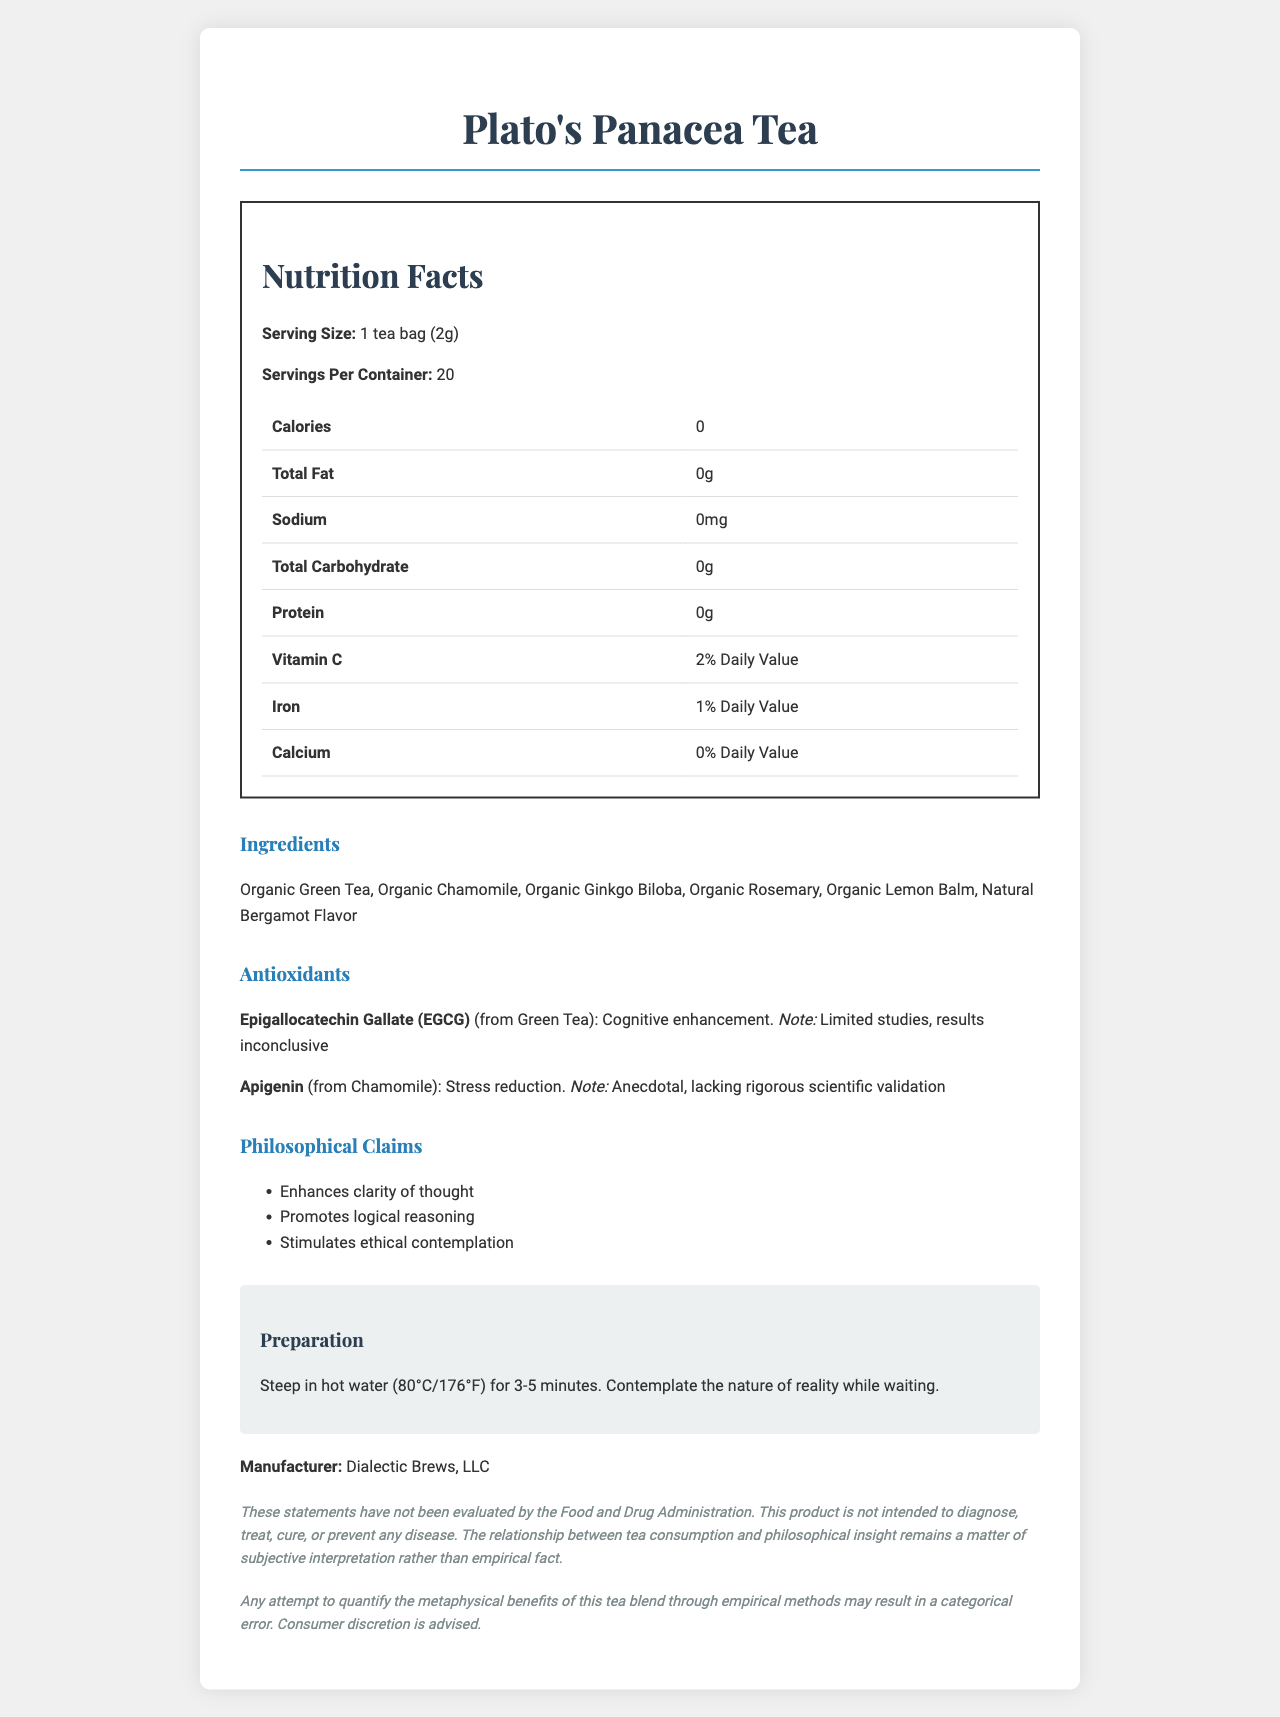what is the serving size of Plato's Panacea Tea? The document specifies the serving size as "1 tea bag (2g)" in the Nutrition Facts section.
Answer: 1 tea bag (2g) how many servings are there per container? The document states "Servings Per Container: 20" in the Nutrition Facts section.
Answer: 20 what is the percentage of Daily Value for Vitamin C in this tea? The document mentions "Vitamin C: 2% Daily Value" in the Nutrition Facts section.
Answer: 2% list three ingredients of this tea blend. The document lists ingredients as "Organic Green Tea, Organic Chamomile, Organic Ginkgo Biloba, Organic Rosemary, Organic Lemon Balm, Natural Bergamot Flavor".
Answer: Organic Green Tea, Organic Chamomile, Organic Ginkgo Biloba which antioxidant is known for cognitive enhancement? A. Apigenin B. EGCG C. Catechin D. Quercetin The document lists "Epigallocatechin Gallate (EGCG)" from Green Tea as having the purported benefit of "Cognitive enhancement".
Answer: B what is the source of Apigenin in this tea? The document specifies that Apigenin comes from Chamomile in the Antioxidants section.
Answer: Chamomile does this tea contain any protein? The document states "Protein: 0g" in the Nutrition Facts section.
Answer: No which company manufactures Plato's Panacea Tea? The document lists the manufacturer as "Dialectic Brews, LLC".
Answer: Dialectic Brews, LLC what temperature should the water be for preparing the tea? The document states "Steep in hot water (80°C/176°F) for 3-5 minutes" in the Preparation section.
Answer: 80°C/176°F has the FDA evaluated the philosophical claims of this tea? The disclaimer in the document mentions, "These statements have not been evaluated by the Food and Drug Administration".
Answer: No which of the following is not an ingredient in the tea? A. Organic Green Tea B. Organic Chamomile C. Organic Peppermint D. Organic Lemon Balm Organic Peppermint is not listed as an ingredient in the document.
Answer: C what percentage of daily value of iron does this tea provide? The document states "Iron: 1% Daily Value" in the Nutrition Facts section.
Answer: 1% summarize the main idea of the document. The document provides detailed information on the nutritional content, natural ingredients, antioxidants, and philosophical claims associated with "Plato's Panacea Tea." It emphasizes the natural composition and potential cognitive and stress-reduction benefits of the tea, while also including disclaimers about the limitations of empirical evidence and FDA evaluation.
Answer: The document is a Nutrition Facts Label for "Plato's Panacea Tea," outlining its nutritional content, ingredients, and antioxidants, with specific sections on philosophical claims and preparation instructions. It highlights that the tea contains no calories, fat, sodium, carbohydrates, or protein and provides minor amounts of Vitamin C and iron. The tea includes natural ingredients like Organic Green Tea and Chamomile, offering antioxidants with purported cognitive and stress reduction benefits, though empirical evidence is limited. It also contains a disclaimer about the philosophical benefits not being FDA evaluated and a legal notice on the metaphysical interpretation. who is the primary target audience for the antioxidant information in this document? The document does not specify an audience for the antioxidant information explicitly.
Answer: Cannot be determined 